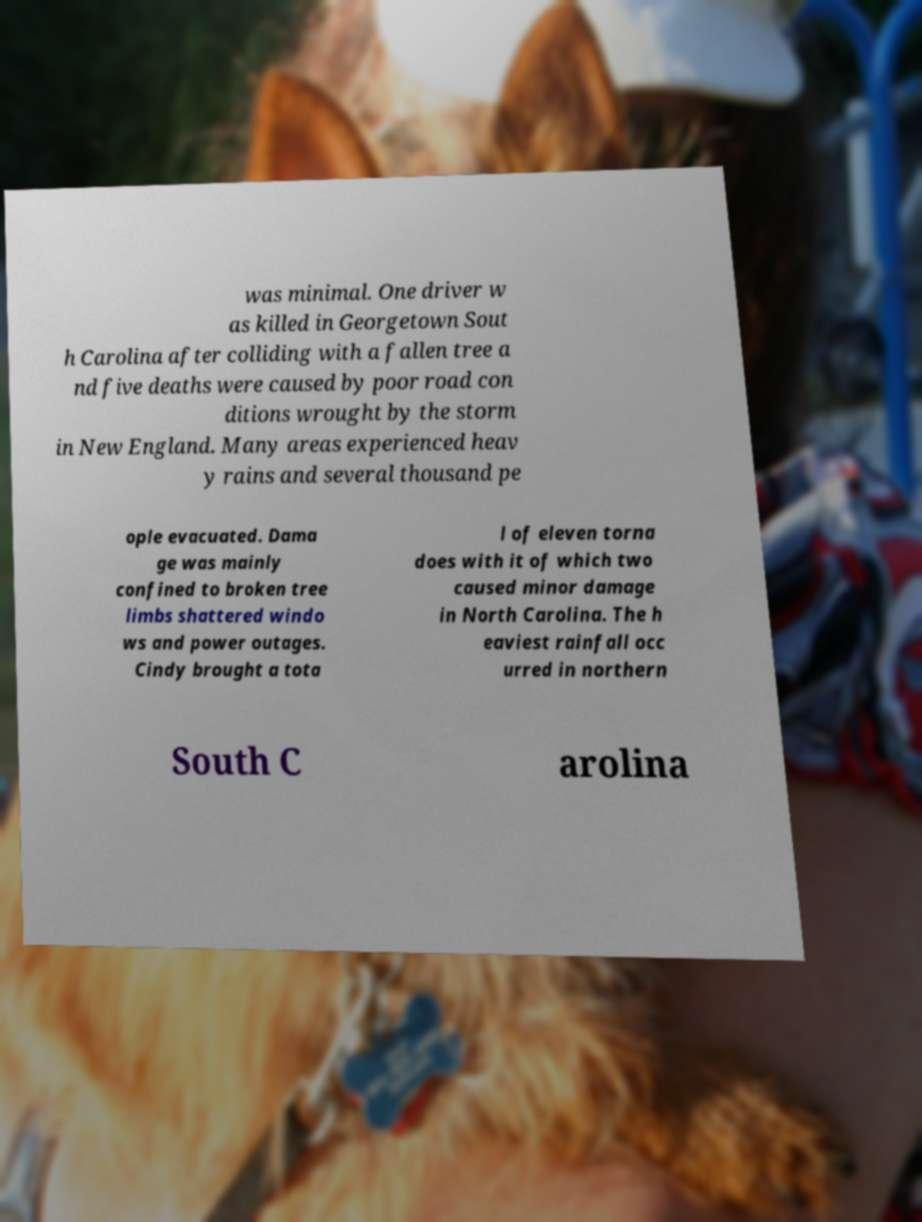Can you accurately transcribe the text from the provided image for me? was minimal. One driver w as killed in Georgetown Sout h Carolina after colliding with a fallen tree a nd five deaths were caused by poor road con ditions wrought by the storm in New England. Many areas experienced heav y rains and several thousand pe ople evacuated. Dama ge was mainly confined to broken tree limbs shattered windo ws and power outages. Cindy brought a tota l of eleven torna does with it of which two caused minor damage in North Carolina. The h eaviest rainfall occ urred in northern South C arolina 